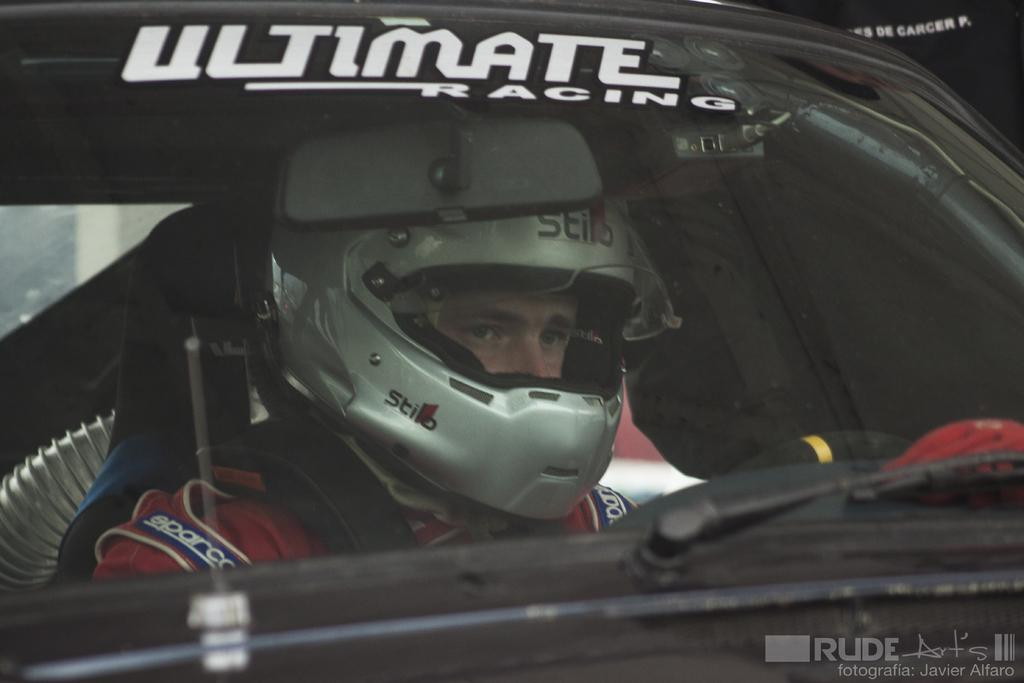Who is present in the image? There is a man in the image. What is the man wearing on his head? The man is wearing a helmet. What type of clothing is the man wearing on his upper body? The man is wearing a jacket. Where is the man located in the image? The man is sitting inside a car. What can be seen in the bottom right corner of the image? There is a watermark in the bottom right corner of the image. What is visible on the left side of the image? There is a wall on the left side of the image. What type of sticks is the carpenter using to build a snowman in the image? There is no carpenter, sticks, or snowman present in the image. 